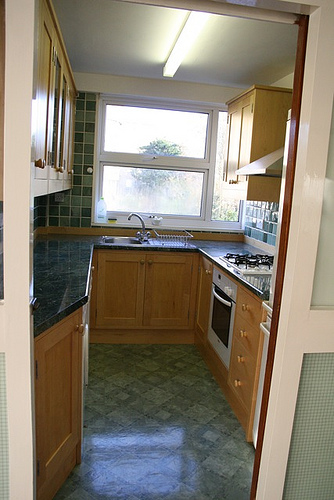If this kitchen could tell a story, what would it be? If this kitchen could tell a story, it might speak of countless family meals prepared with love and care. It would recount busy mornings with the smell of coffee and fresh toast, lazy Sunday afternoons filled with the scent of baked cookies, and festive dinners where laughter and conversations filled the room. This kitchen has seen generations come together, sharing recipes and creating memories that linger in every corner. 